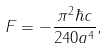<formula> <loc_0><loc_0><loc_500><loc_500>F = - \frac { \pi ^ { 2 } \hbar { c } } { 2 4 0 a ^ { 4 } } ,</formula> 